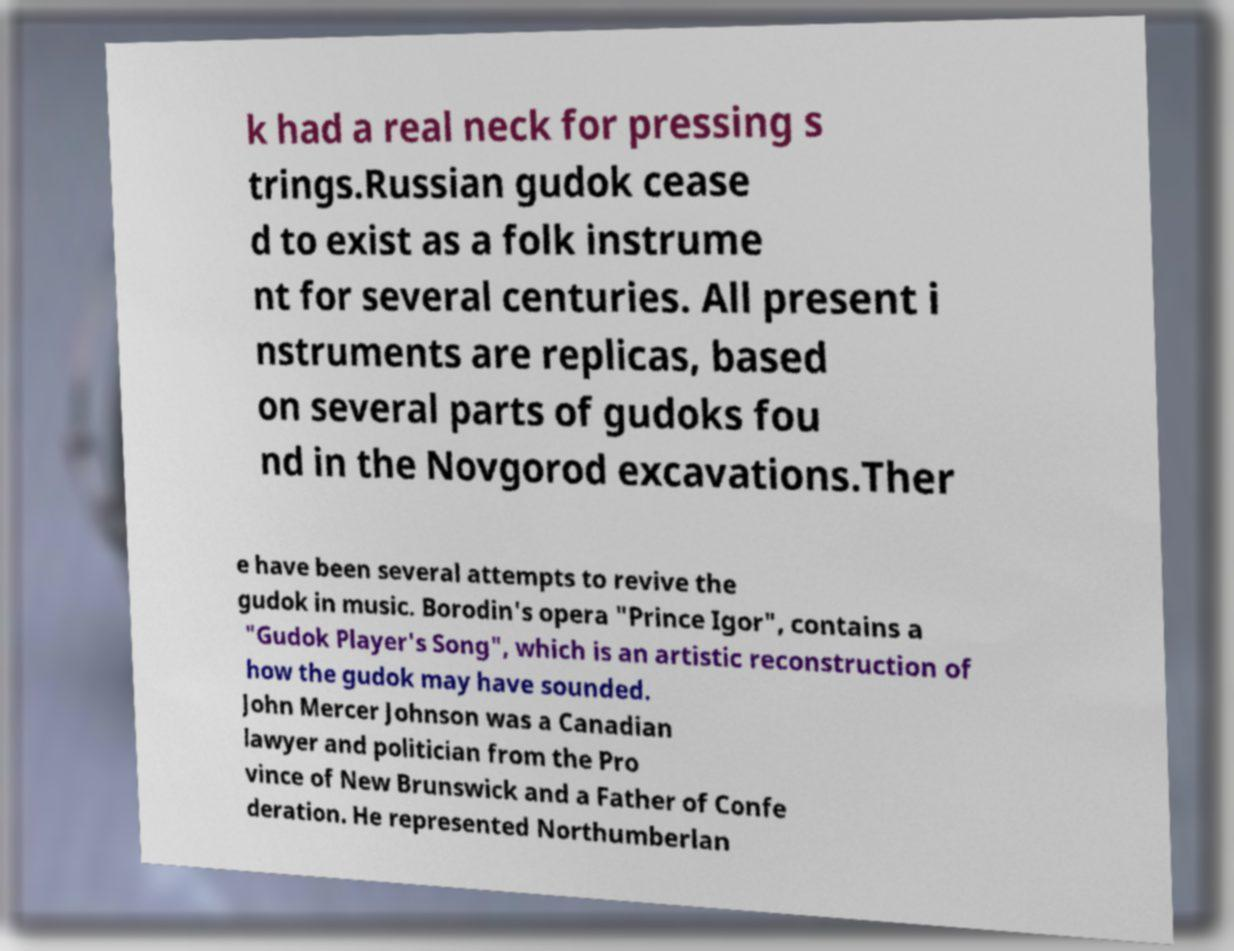Could you extract and type out the text from this image? k had a real neck for pressing s trings.Russian gudok cease d to exist as a folk instrume nt for several centuries. All present i nstruments are replicas, based on several parts of gudoks fou nd in the Novgorod excavations.Ther e have been several attempts to revive the gudok in music. Borodin's opera "Prince Igor", contains a "Gudok Player's Song", which is an artistic reconstruction of how the gudok may have sounded. John Mercer Johnson was a Canadian lawyer and politician from the Pro vince of New Brunswick and a Father of Confe deration. He represented Northumberlan 